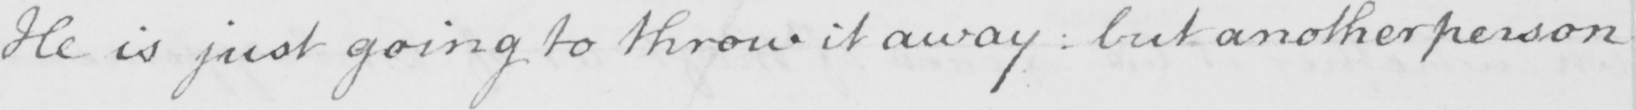Can you tell me what this handwritten text says? He is just going to throw it away  :  but another person 